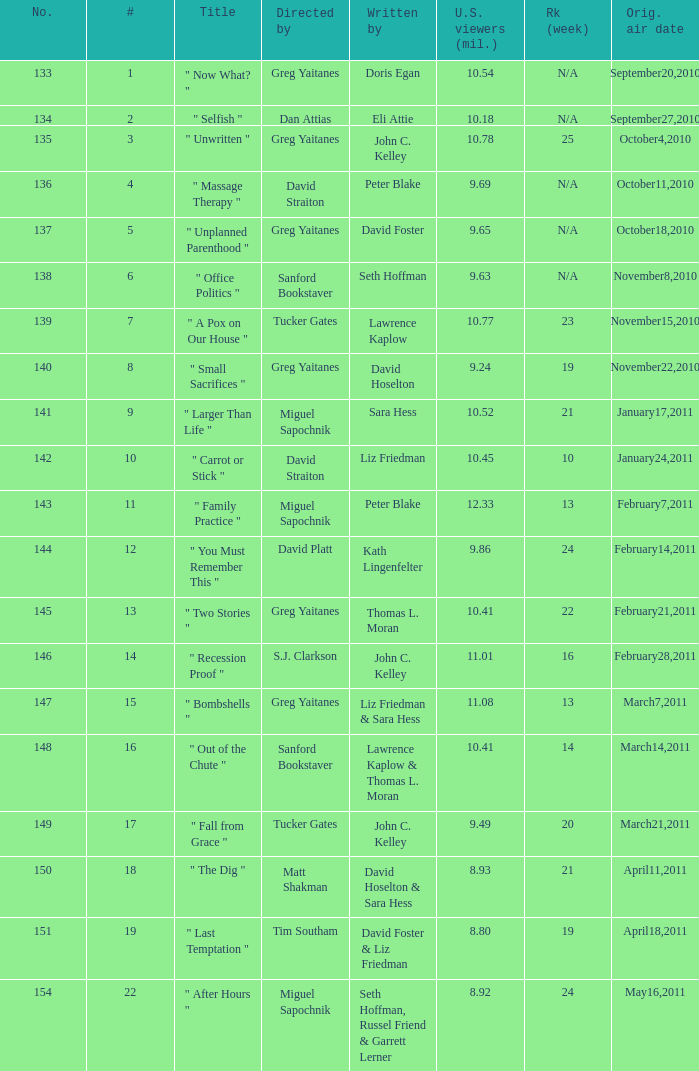How many episodes were written by seth hoffman, russel friend & garrett lerner? 1.0. 